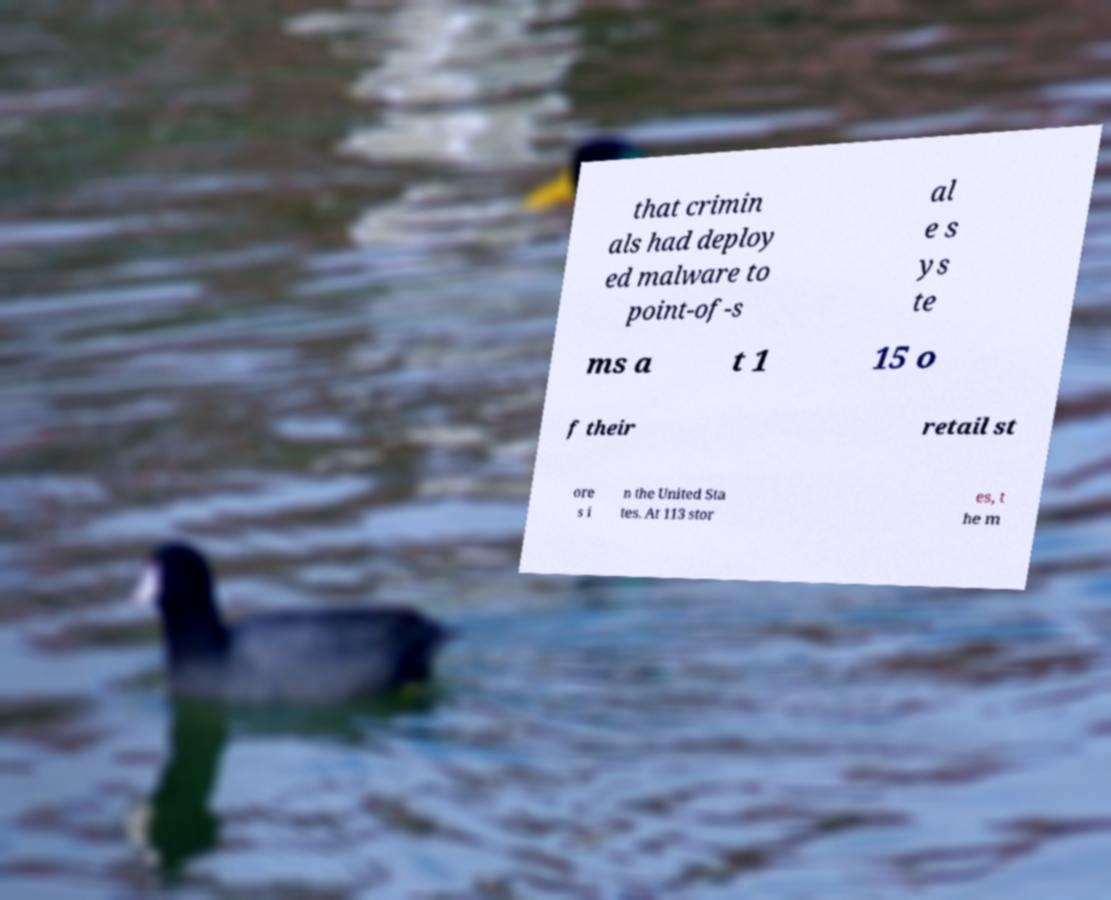Please read and relay the text visible in this image. What does it say? that crimin als had deploy ed malware to point-of-s al e s ys te ms a t 1 15 o f their retail st ore s i n the United Sta tes. At 113 stor es, t he m 